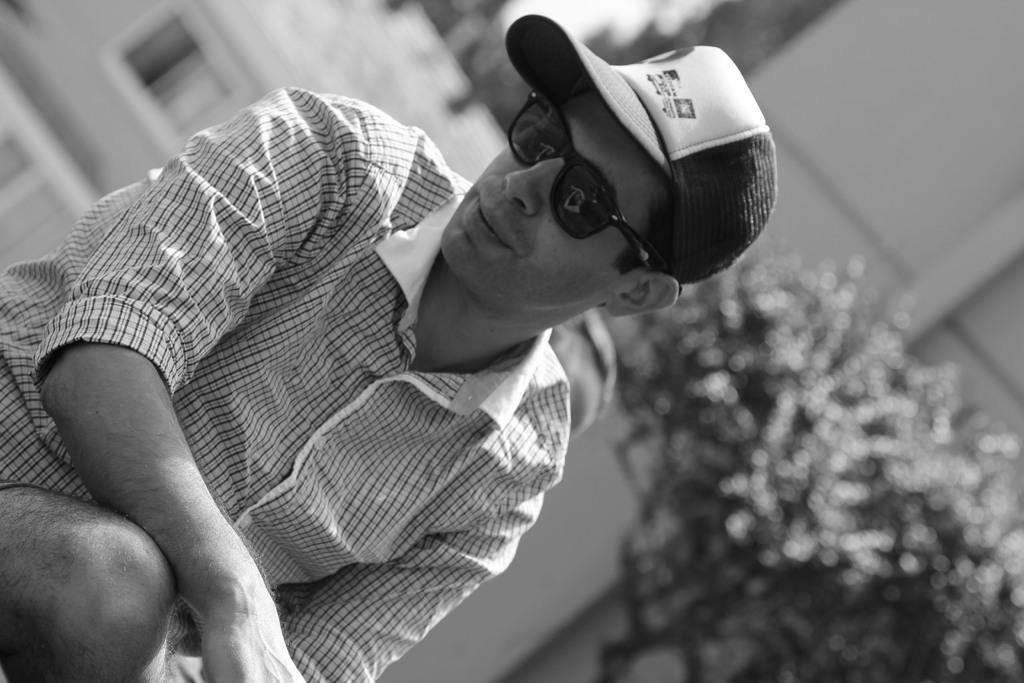What is the color scheme of the image? The image is black and white. Can you describe the person in the image? The person is wearing sunglasses and a cap. What can be seen in the background of the image? There is a tree in the background of the image. How would you describe the clarity of the image? The image is blurred. What type of needle is being used by the person in the image? There is no needle present in the image; the person is wearing sunglasses and a cap. How many yams are visible in the image? There are no yams present in the image; it features a person wearing sunglasses and a cap with a tree in the background. 